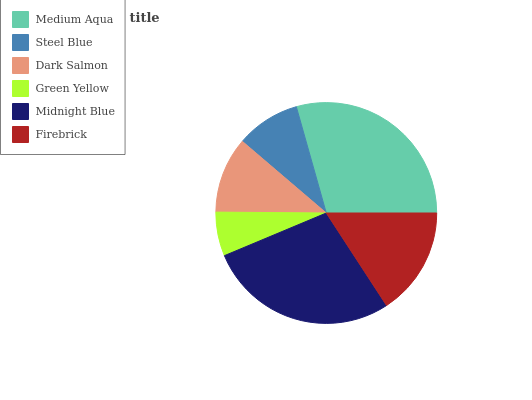Is Green Yellow the minimum?
Answer yes or no. Yes. Is Medium Aqua the maximum?
Answer yes or no. Yes. Is Steel Blue the minimum?
Answer yes or no. No. Is Steel Blue the maximum?
Answer yes or no. No. Is Medium Aqua greater than Steel Blue?
Answer yes or no. Yes. Is Steel Blue less than Medium Aqua?
Answer yes or no. Yes. Is Steel Blue greater than Medium Aqua?
Answer yes or no. No. Is Medium Aqua less than Steel Blue?
Answer yes or no. No. Is Firebrick the high median?
Answer yes or no. Yes. Is Dark Salmon the low median?
Answer yes or no. Yes. Is Green Yellow the high median?
Answer yes or no. No. Is Midnight Blue the low median?
Answer yes or no. No. 